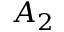<formula> <loc_0><loc_0><loc_500><loc_500>A _ { 2 }</formula> 